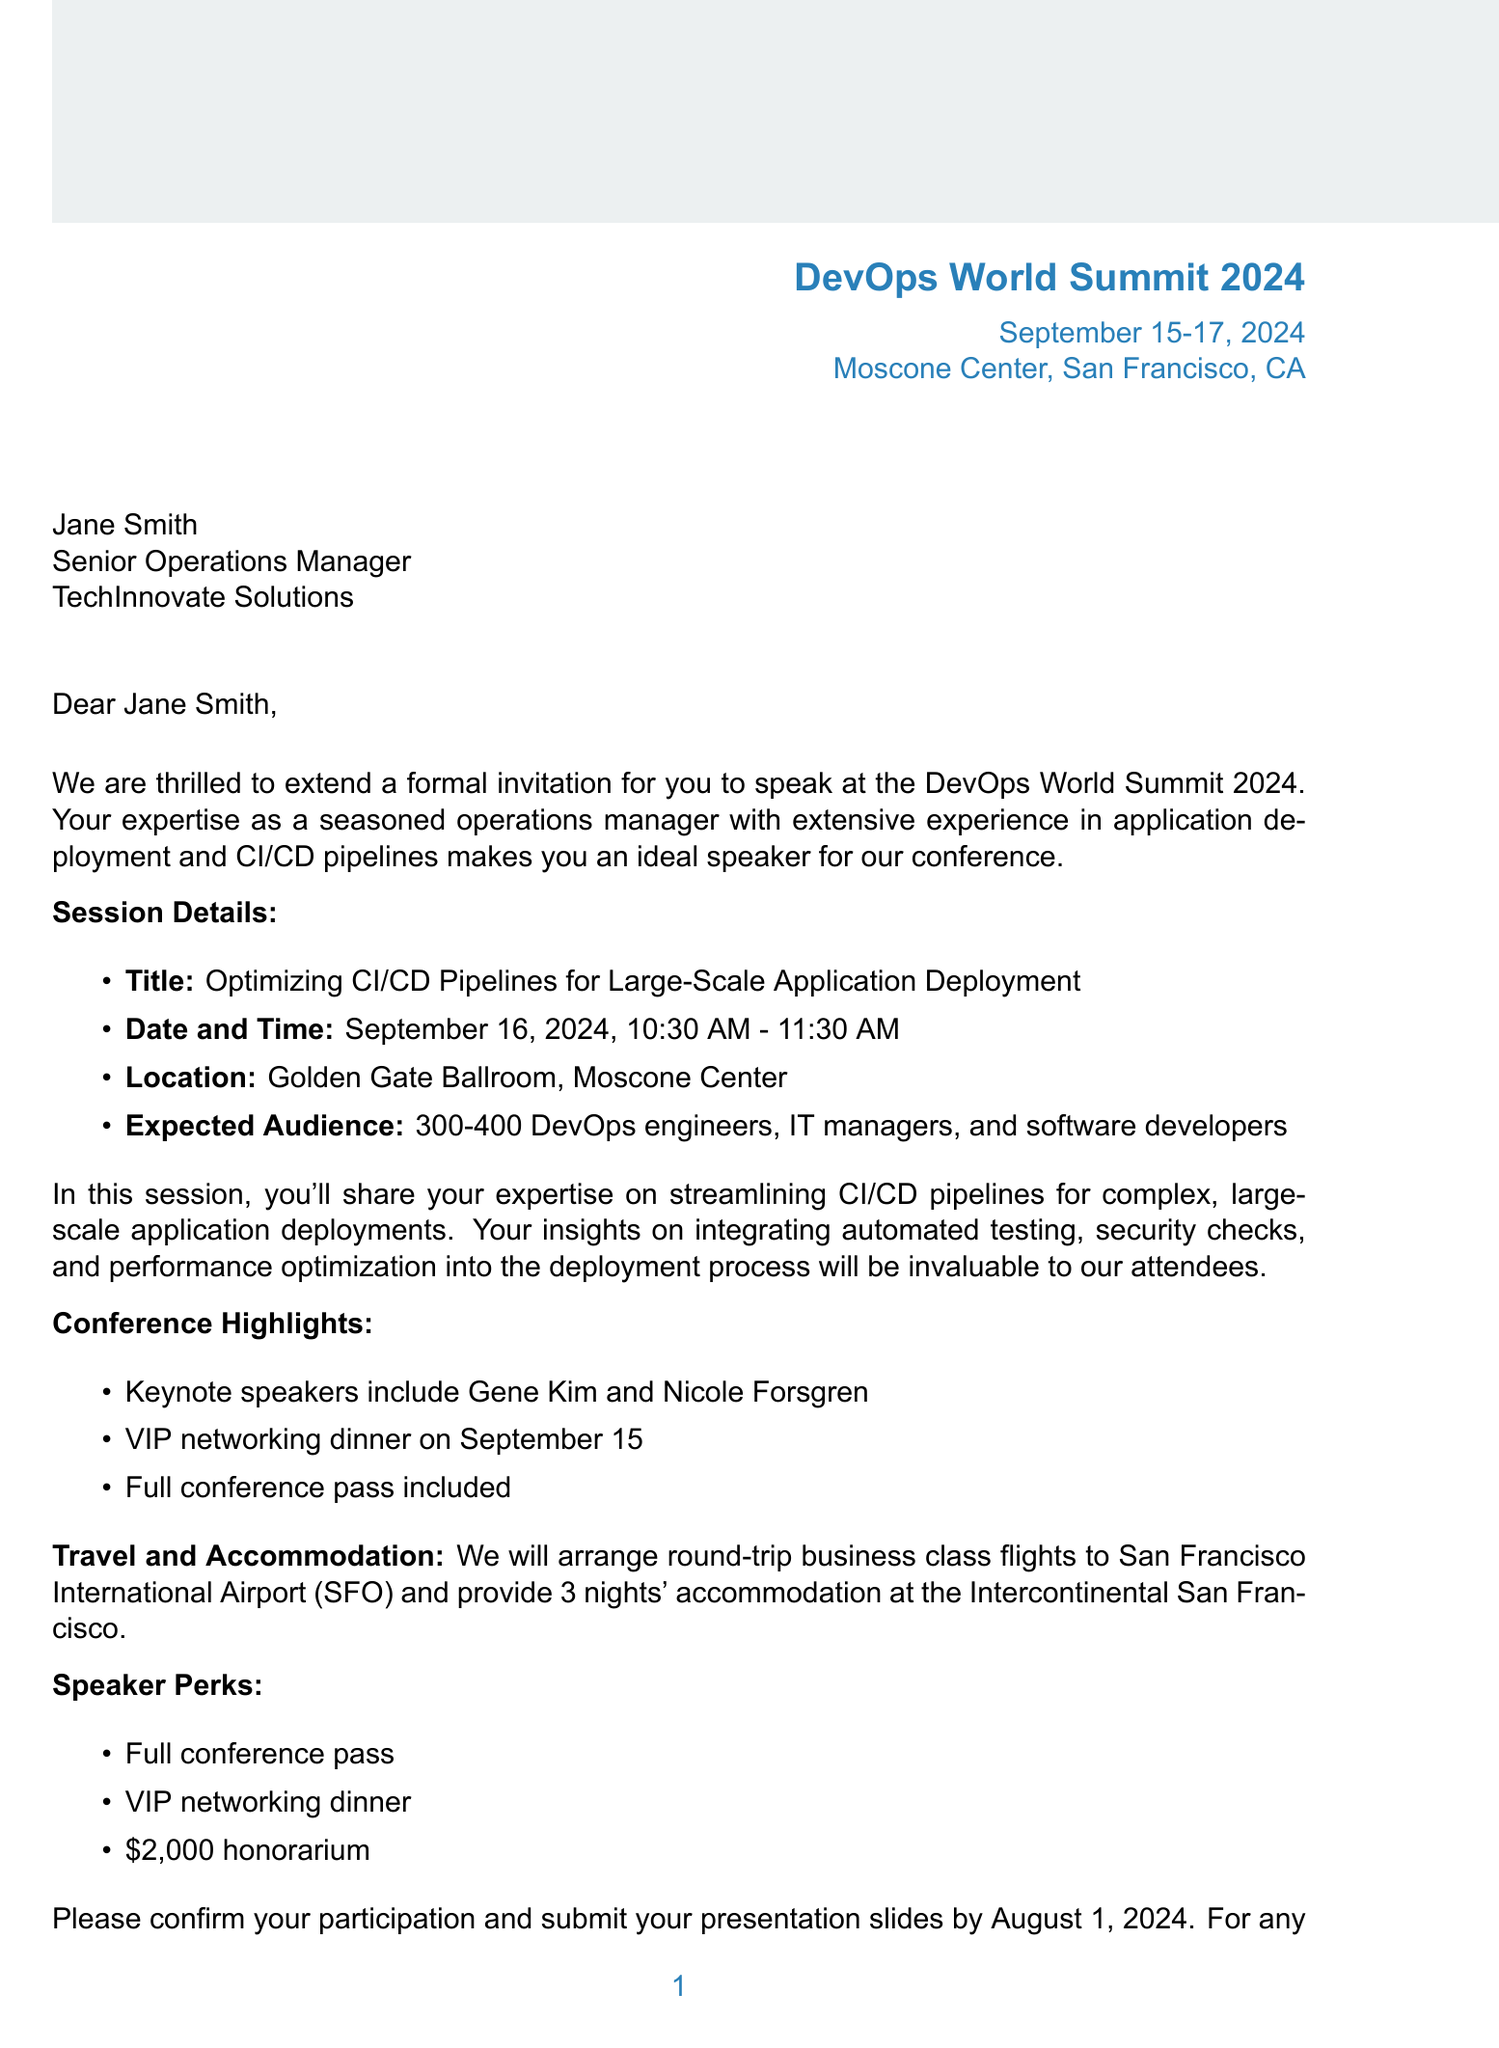What is the name of the conference? The document states that the conference is called DevOps World Summit 2024.
Answer: DevOps World Summit 2024 What are the dates of the conference? The document specifies the dates as September 15-17, 2024.
Answer: September 15-17, 2024 Who is the intended speaker? The invitation is addressed to Jane Smith.
Answer: Jane Smith What is the title of the speaker session? The title listed for the session is Optimizing CI/CD Pipelines for Large-Scale Application Deployment.
Answer: Optimizing CI/CD Pipelines for Large-Scale Application Deployment What is the expected audience size? The document mentions an expected audience of 300-400 attendees.
Answer: 300-400 attendees What is the honorarium for speaking? The document states that the speaker will receive an honorarium of $2,000.
Answer: $2,000 What type of travel arrangements will be provided? The document mentions that round-trip business class flights will be arranged.
Answer: Round-trip business class flights What is required for confirming participation? The document states that participation must be confirmed and presentation slides submitted by a specific date.
Answer: By August 1, 2024 What is a unique feature of the event for speakers? The document lists a VIP networking dinner as a perk for speakers.
Answer: VIP networking dinner Who is the contact person for questions? Emily Chen is identified as the Speaker Coordinator for inquiries.
Answer: Emily Chen 